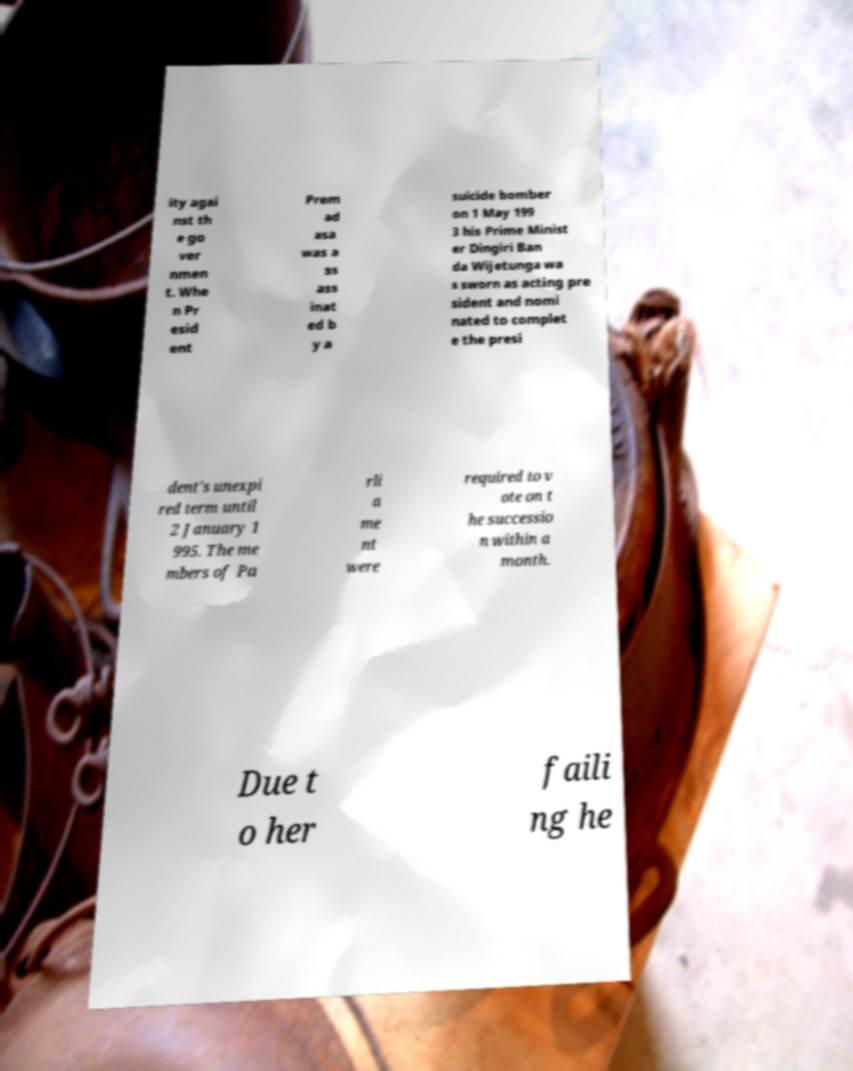Please identify and transcribe the text found in this image. ity agai nst th e go ver nmen t. Whe n Pr esid ent Prem ad asa was a ss ass inat ed b y a suicide bomber on 1 May 199 3 his Prime Minist er Dingiri Ban da Wijetunga wa s sworn as acting pre sident and nomi nated to complet e the presi dent's unexpi red term until 2 January 1 995. The me mbers of Pa rli a me nt were required to v ote on t he successio n within a month. Due t o her faili ng he 